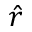Convert formula to latex. <formula><loc_0><loc_0><loc_500><loc_500>\hat { r }</formula> 